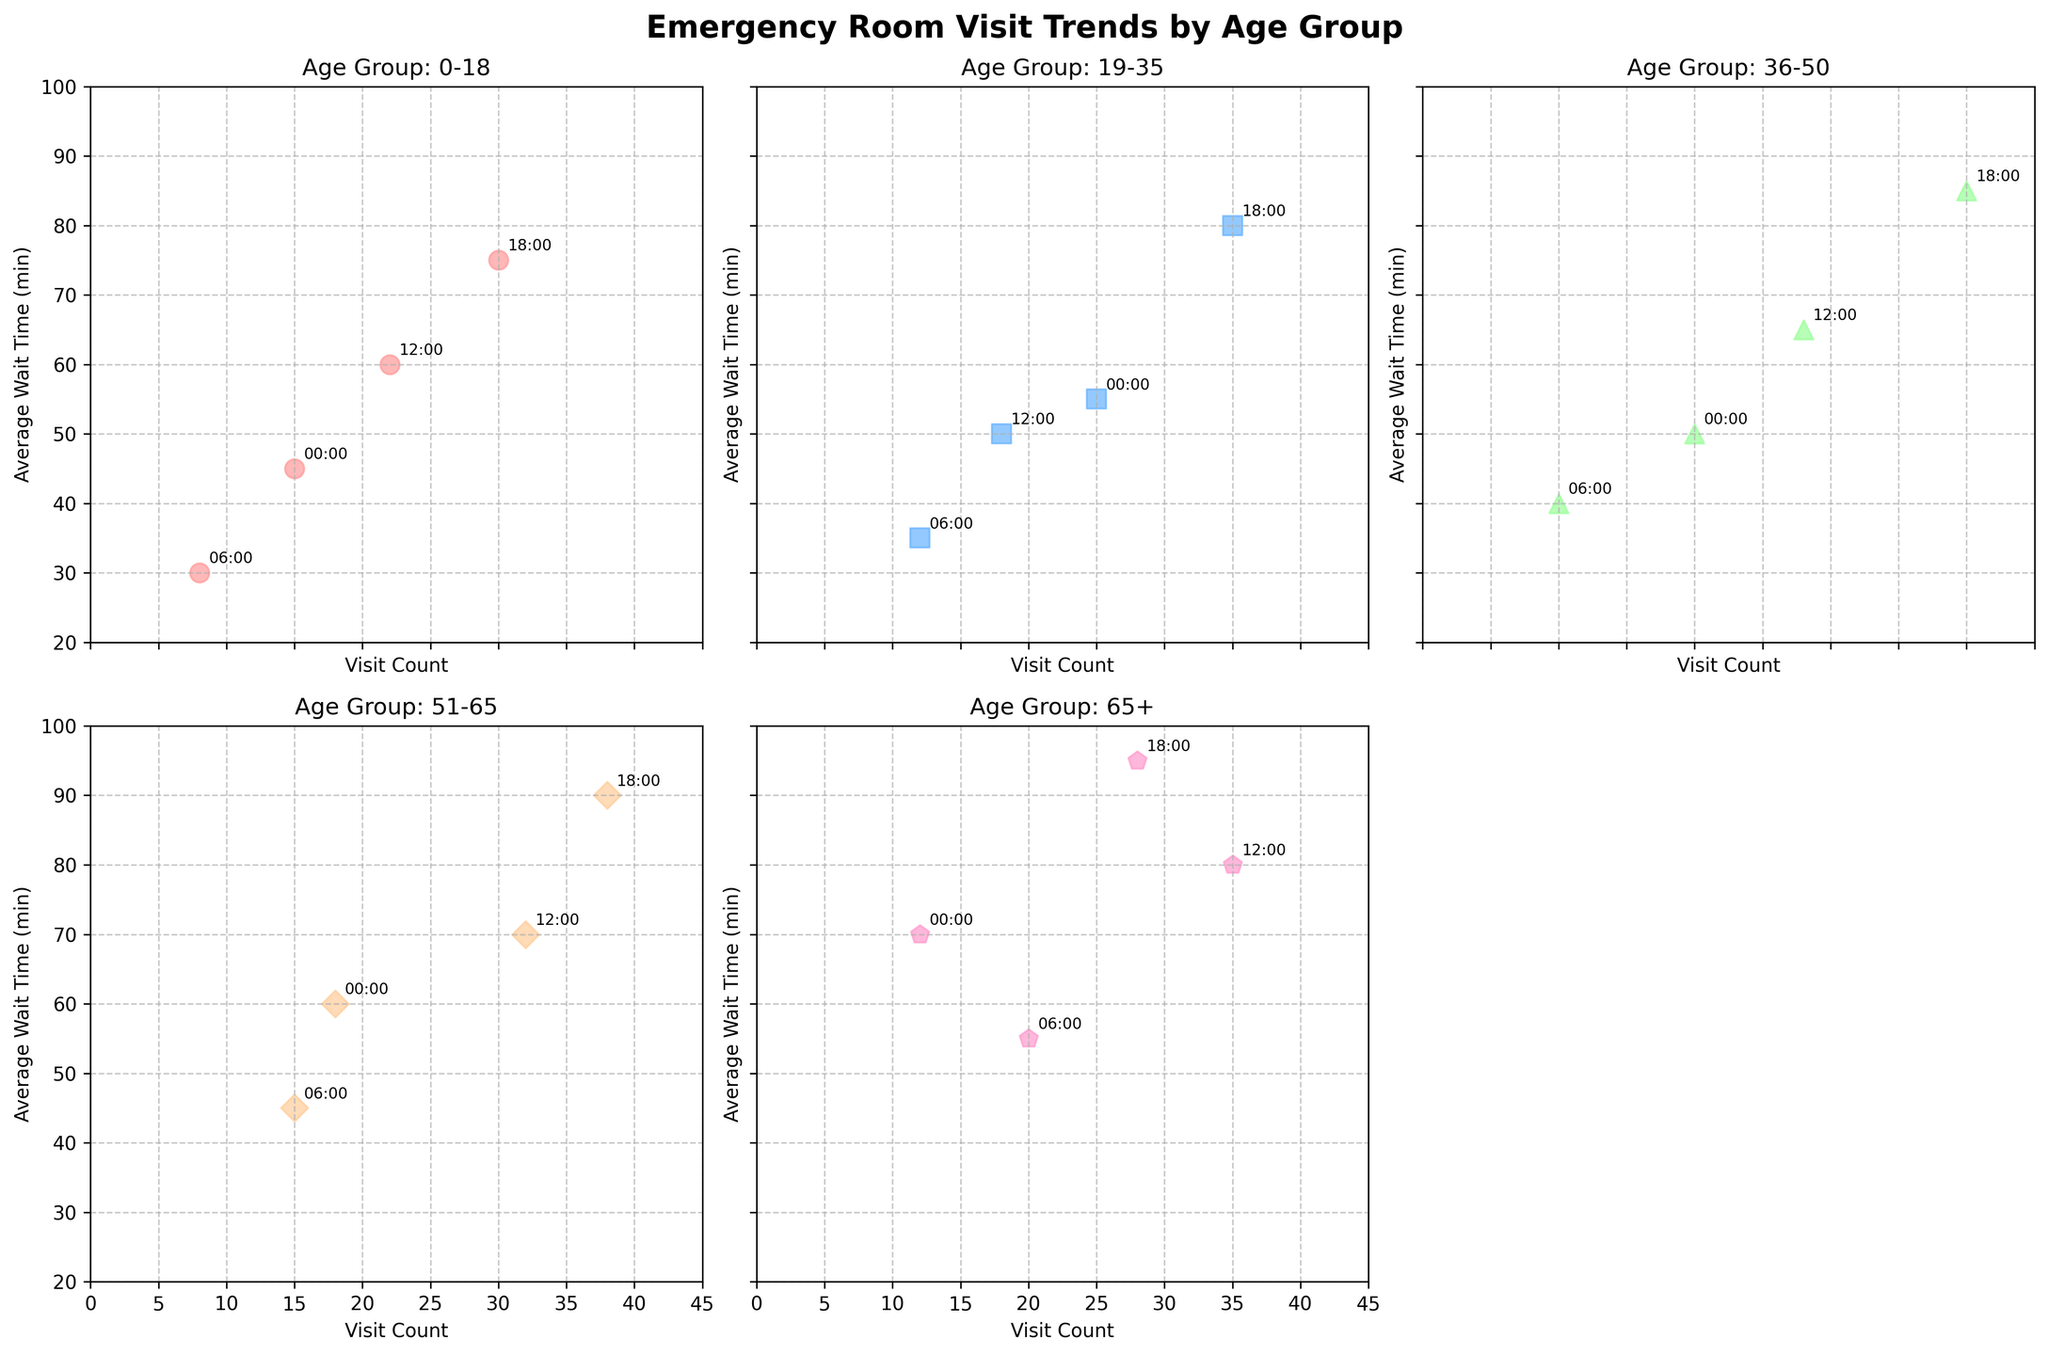What is the main title of the plot? The main title of the plot is located at the top center of the figure. It indicates the subject of the data being visualized.
Answer: Emergency Room Visit Trends by Age Group How many age groups are represented in the subplot? Each subplot corresponds to a different age group. By counting, we can see that there are 5 different age groups labeled: 0-18, 19-35, 36-50, 51-65, and 65+.
Answer: 5 For the 65+ age group, what is the average wait time at 6:00? In the subplot for the 65+ age group, locate the point marked "06:00" and read the corresponding average wait time from the y-axis.
Answer: 55 minutes Which age group has the highest visit count during the 18:00 time period? Find the points marked "18:00" in each subplot and compare their visit counts. Look at the x-axis of each subplot to find the highest value.
Answer: 36-50 What is the overall trend in average wait time as the visit count increases in the 19-35 age group? In the 19-35 age group subplot, observe the points from left to right and note the trend of the average wait time on the y-axis as the visit count on the x-axis increases.
Answer: It increases How does the visit count of the 0-18 age group at 12:00 compare to 18:00? In the 0-18 age group subplot, identify the points for "12:00" and "18:00" and compare their positions along the x-axis. The point further right represents a higher visit count.
Answer: The visit count at 18:00 is higher Which time period has the lowest average wait time for the age group 51-65? In the 51-65 age group subplot, read the average wait times for each time period label and identify the smallest value on the y-axis.
Answer: 06:00 What is the difference in average wait time between the 12:00 and 18:00 time periods for the 36-50 age group? For the 36-50 age group subplot, find the average wait times for "12:00" and "18:00," then subtract the 12:00 value from the 18:00 value.
Answer: 20 minutes Identify which age group's wait times are annotated in the 3rd column and 2nd row subplot. Specifically, look at the bottom row second subplot and read its title to determine the age group.
Answer: 51-65 